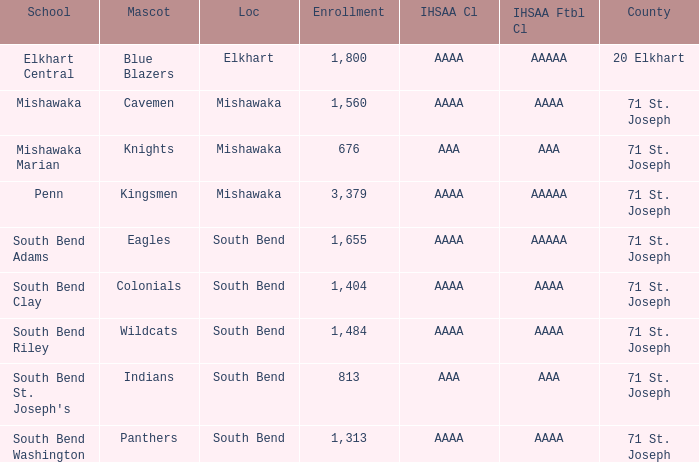In south bend, which academic establishment has indians as their mascot? South Bend St. Joseph's. 